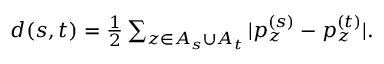Convert formula to latex. <formula><loc_0><loc_0><loc_500><loc_500>\begin{array} { r } { d ( s , t ) = \frac { 1 } { 2 } \sum _ { z \in A _ { s } \cup A _ { t } } | p _ { z } ^ { ( s ) } - p _ { z } ^ { ( t ) } | . } \end{array}</formula> 